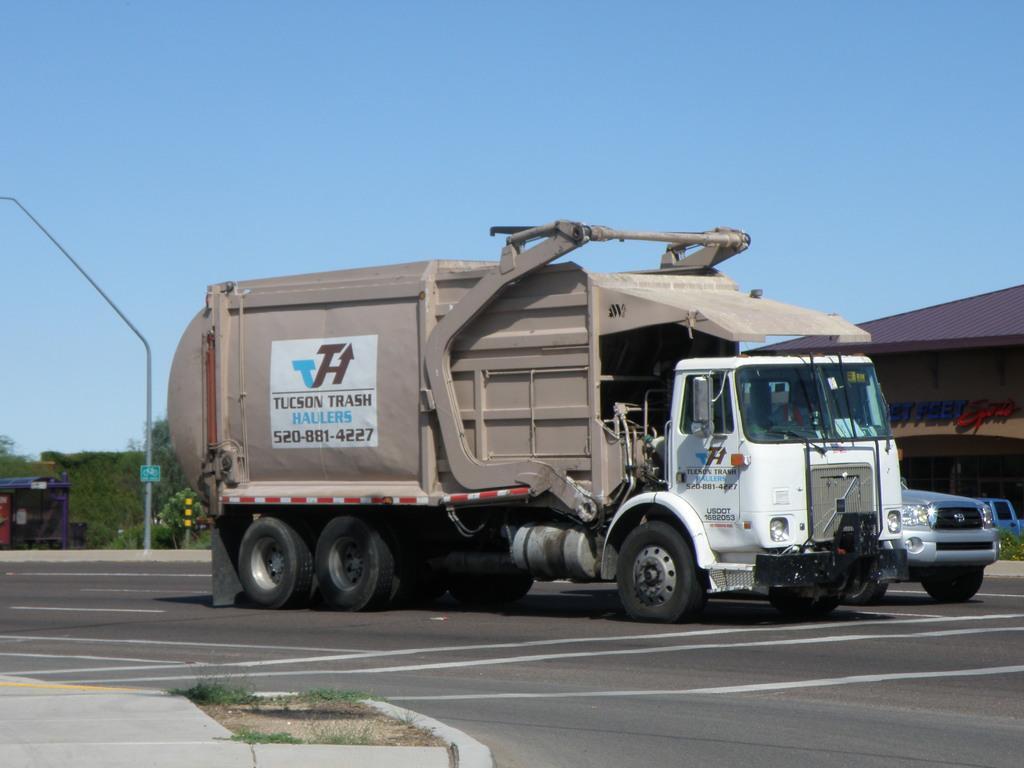Can you describe this image briefly? In this image there are vehicles on the road. On the left there is a pole. In the background there is a shed and we can see trees. At the top there is sky. 